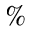Convert formula to latex. <formula><loc_0><loc_0><loc_500><loc_500>\%</formula> 